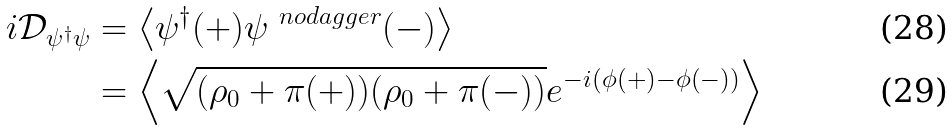<formula> <loc_0><loc_0><loc_500><loc_500>i { \mathcal { D } } _ { \psi ^ { \dagger } \psi } & = \left < \psi ^ { \dagger } ( + ) \psi ^ { \ n o d a g g e r } ( - ) \right > \\ & = \left < \sqrt { ( \rho _ { 0 } + \pi ( + ) ) ( \rho _ { 0 } + \pi ( - ) ) } e ^ { - i ( \phi ( + ) - \phi ( - ) ) } \right ></formula> 